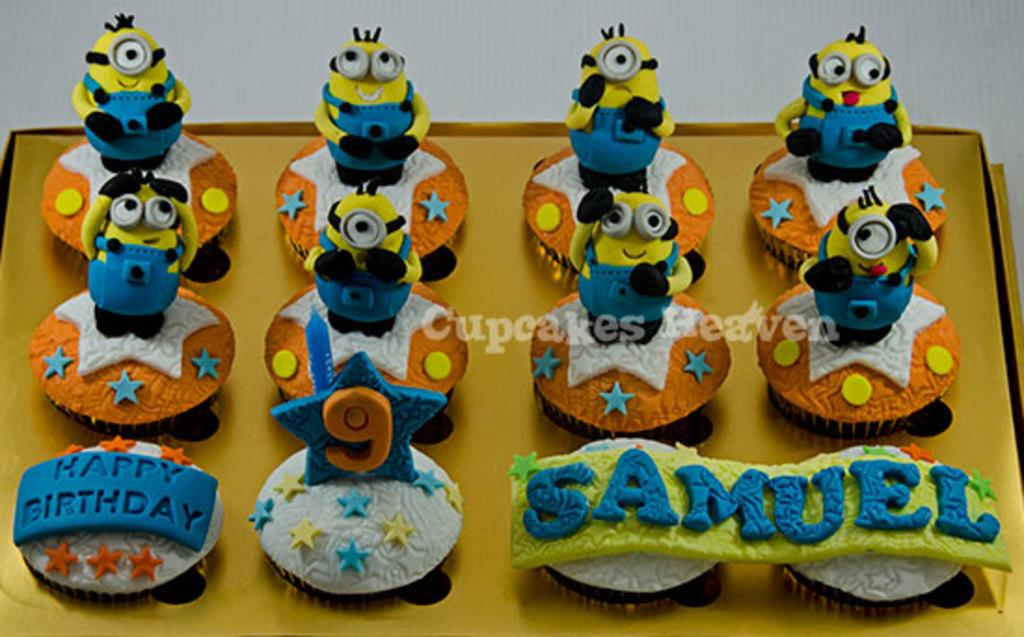What objects are present in the image? There are toys in the image. Where are the toys placed? The toys are placed on a cardboard. Is there any additional element in the foreground of the image? Yes, there is a watermark in the foreground of the image. What type of boundary can be seen in the image? There is no boundary present in the image; it features toys placed on a cardboard with a watermark in the foreground. 